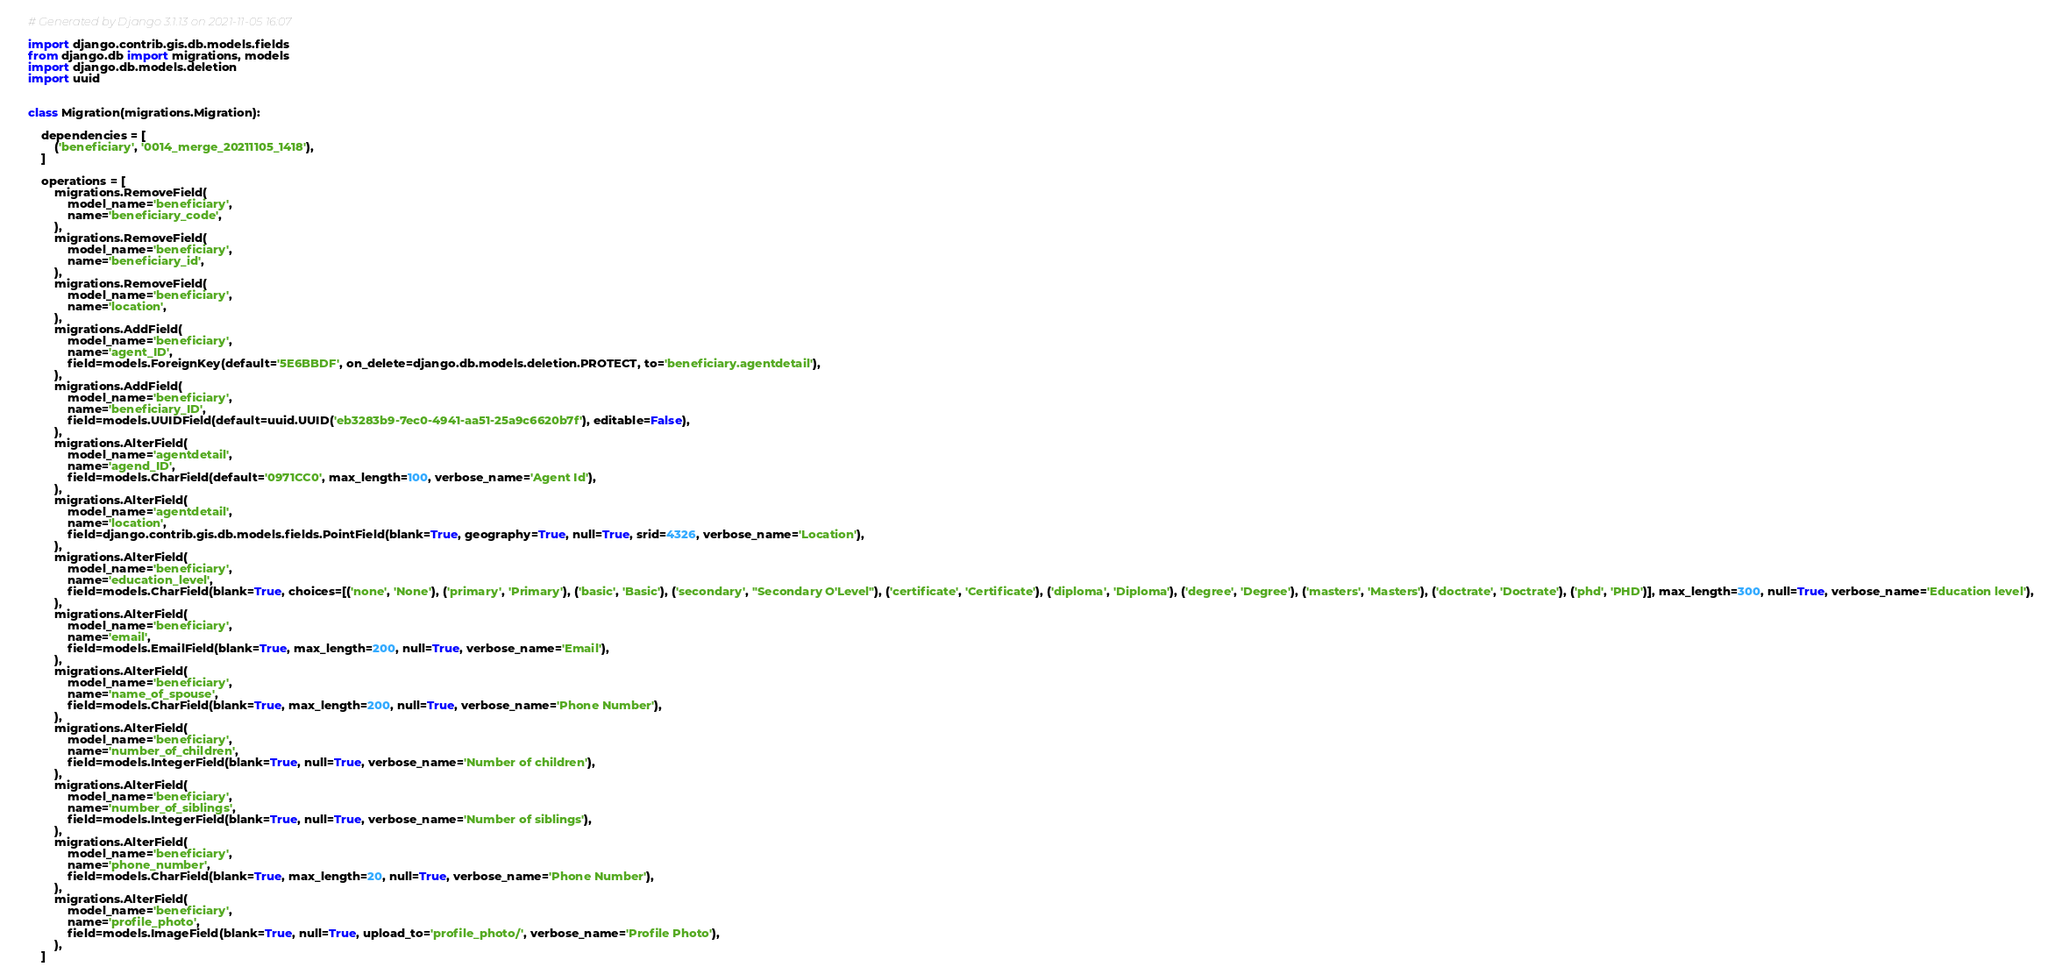Convert code to text. <code><loc_0><loc_0><loc_500><loc_500><_Python_># Generated by Django 3.1.13 on 2021-11-05 16:07

import django.contrib.gis.db.models.fields
from django.db import migrations, models
import django.db.models.deletion
import uuid


class Migration(migrations.Migration):

    dependencies = [
        ('beneficiary', '0014_merge_20211105_1418'),
    ]

    operations = [
        migrations.RemoveField(
            model_name='beneficiary',
            name='beneficiary_code',
        ),
        migrations.RemoveField(
            model_name='beneficiary',
            name='beneficiary_id',
        ),
        migrations.RemoveField(
            model_name='beneficiary',
            name='location',
        ),
        migrations.AddField(
            model_name='beneficiary',
            name='agent_ID',
            field=models.ForeignKey(default='5E6BBDF', on_delete=django.db.models.deletion.PROTECT, to='beneficiary.agentdetail'),
        ),
        migrations.AddField(
            model_name='beneficiary',
            name='beneficiary_ID',
            field=models.UUIDField(default=uuid.UUID('eb3283b9-7ec0-4941-aa51-25a9c6620b7f'), editable=False),
        ),
        migrations.AlterField(
            model_name='agentdetail',
            name='agend_ID',
            field=models.CharField(default='0971CC0', max_length=100, verbose_name='Agent Id'),
        ),
        migrations.AlterField(
            model_name='agentdetail',
            name='location',
            field=django.contrib.gis.db.models.fields.PointField(blank=True, geography=True, null=True, srid=4326, verbose_name='Location'),
        ),
        migrations.AlterField(
            model_name='beneficiary',
            name='education_level',
            field=models.CharField(blank=True, choices=[('none', 'None'), ('primary', 'Primary'), ('basic', 'Basic'), ('secondary', "Secondary O'Level"), ('certificate', 'Certificate'), ('diploma', 'Diploma'), ('degree', 'Degree'), ('masters', 'Masters'), ('doctrate', 'Doctrate'), ('phd', 'PHD')], max_length=300, null=True, verbose_name='Education level'),
        ),
        migrations.AlterField(
            model_name='beneficiary',
            name='email',
            field=models.EmailField(blank=True, max_length=200, null=True, verbose_name='Email'),
        ),
        migrations.AlterField(
            model_name='beneficiary',
            name='name_of_spouse',
            field=models.CharField(blank=True, max_length=200, null=True, verbose_name='Phone Number'),
        ),
        migrations.AlterField(
            model_name='beneficiary',
            name='number_of_children',
            field=models.IntegerField(blank=True, null=True, verbose_name='Number of children'),
        ),
        migrations.AlterField(
            model_name='beneficiary',
            name='number_of_siblings',
            field=models.IntegerField(blank=True, null=True, verbose_name='Number of siblings'),
        ),
        migrations.AlterField(
            model_name='beneficiary',
            name='phone_number',
            field=models.CharField(blank=True, max_length=20, null=True, verbose_name='Phone Number'),
        ),
        migrations.AlterField(
            model_name='beneficiary',
            name='profile_photo',
            field=models.ImageField(blank=True, null=True, upload_to='profile_photo/', verbose_name='Profile Photo'),
        ),
    ]
</code> 